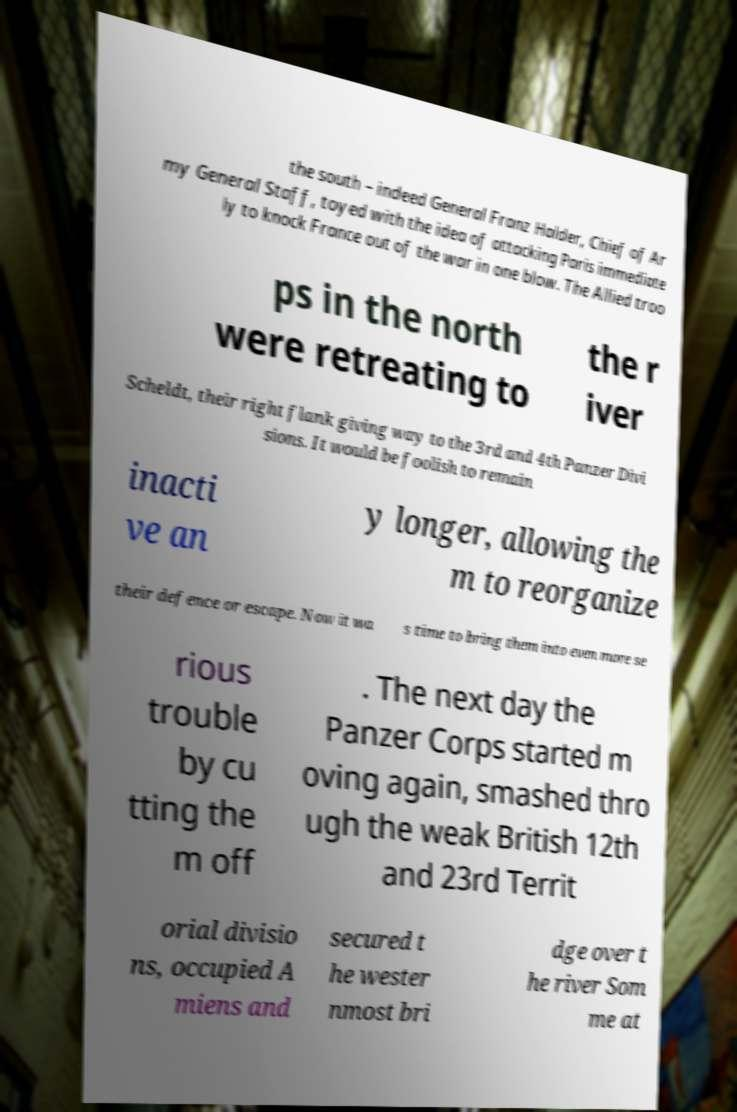Can you accurately transcribe the text from the provided image for me? the south – indeed General Franz Halder, Chief of Ar my General Staff, toyed with the idea of attacking Paris immediate ly to knock France out of the war in one blow. The Allied troo ps in the north were retreating to the r iver Scheldt, their right flank giving way to the 3rd and 4th Panzer Divi sions. It would be foolish to remain inacti ve an y longer, allowing the m to reorganize their defence or escape. Now it wa s time to bring them into even more se rious trouble by cu tting the m off . The next day the Panzer Corps started m oving again, smashed thro ugh the weak British 12th and 23rd Territ orial divisio ns, occupied A miens and secured t he wester nmost bri dge over t he river Som me at 